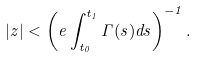<formula> <loc_0><loc_0><loc_500><loc_500>\left | z \right | < \left ( e \int _ { t _ { 0 } } ^ { t _ { 1 } } \Gamma ( s ) d s \right ) ^ { - 1 } .</formula> 